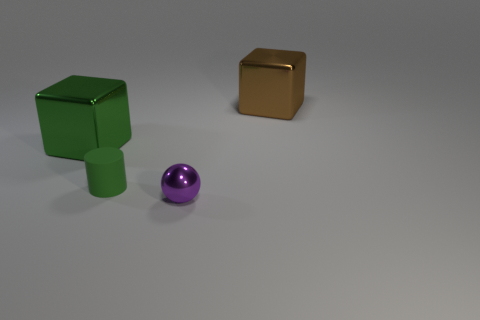Is there any other thing that is the same material as the green cylinder?
Make the answer very short. No. How many small blue blocks have the same material as the big brown cube?
Ensure brevity in your answer.  0. There is a big metallic object that is right of the green rubber thing; is its shape the same as the large green shiny object?
Offer a very short reply. Yes. The metallic object that is in front of the tiny green cylinder has what shape?
Offer a very short reply. Sphere. There is a metallic object that is the same color as the cylinder; what size is it?
Keep it short and to the point. Large. What material is the cylinder?
Your answer should be compact. Rubber. The shiny sphere that is the same size as the matte object is what color?
Keep it short and to the point. Purple. There is a object that is the same color as the tiny rubber cylinder; what shape is it?
Keep it short and to the point. Cube. Is the brown thing the same shape as the green shiny thing?
Your response must be concise. Yes. There is a object that is both on the left side of the purple metal sphere and in front of the large green metal cube; what is it made of?
Offer a very short reply. Rubber. 